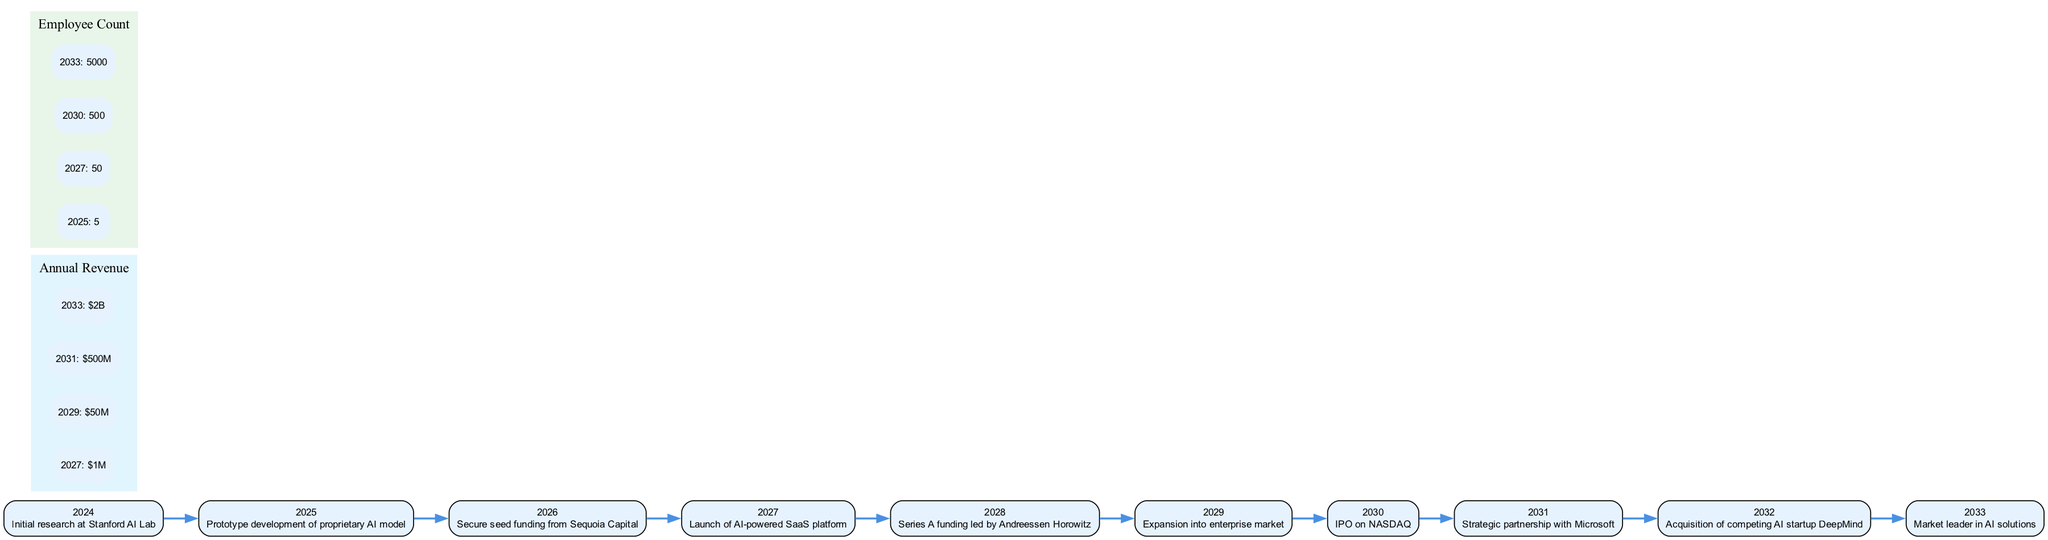What is the first milestone in the timeline? The first milestone listed in the timeline is "Initial research at Stanford AI Lab" occurring in the year 2024.
Answer: Initial research at Stanford AI Lab In what year does the company launch its AI-powered SaaS platform? By following the timeline, we see that the company launches its AI-powered SaaS platform in the year 2027.
Answer: 2027 How much annual revenue does the company project by the year 2033? The projected annual revenue for the year 2033, as indicated in the growth indicators, is "$2B".
Answer: $2B What is the employee count in the year 2030? The employee count for the year 2030 is explicitly noted in the timeline, which states there will be "500" employees at that time.
Answer: 500 What milestone occurred immediately before the acquisition of DeepMind? The acquisition of competing AI startup DeepMind happened in 2032, preceded by a strategic partnership with Microsoft in 2031.
Answer: Strategic partnership with Microsoft What indicates the company's transition to the enterprise market, and when did it happen? The timeline indicates an "Expansion into enterprise market" milestone occurring in 2029, which signifies the company’s transition to this sector.
Answer: Expansion into enterprise market in 2029 What is the trend of annual revenue growth from 2027 to 2033? Reviewing the annual revenue growth data, the revenue increases from "$1M" in 2027 to "$2B" in 2033, indicating a substantial upward trend.
Answer: Substantial upward trend Which milestone is associated with securing seed funding? The milestone related to securing seed funding is "Secure seed funding from Sequoia Capital," which took place in 2026.
Answer: Secure seed funding from Sequoia Capital How many years pass from prototype development to IPO? From the prototype development in 2025 to the IPO in 2030, there are 5 years that pass.
Answer: 5 years 